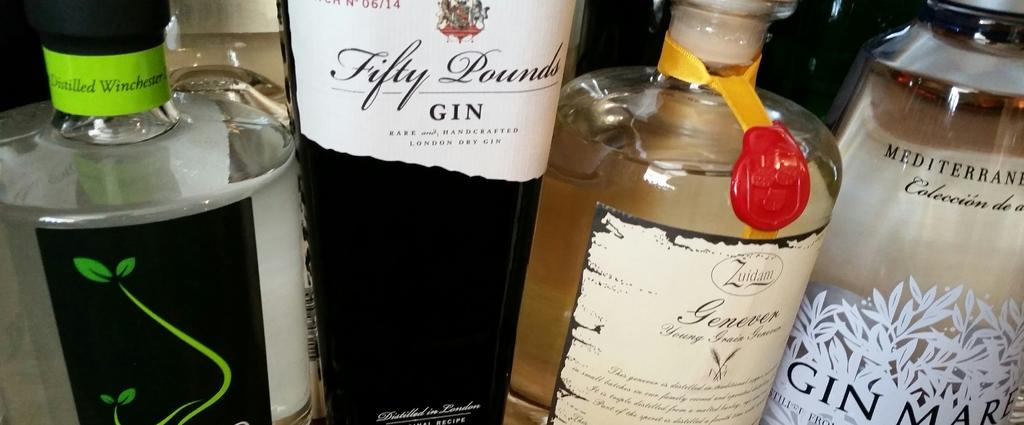<image>
Offer a succinct explanation of the picture presented. A close up of four gin labels, one called fifty pounds, another Gin Mare and another distilled winchester on a green label. 